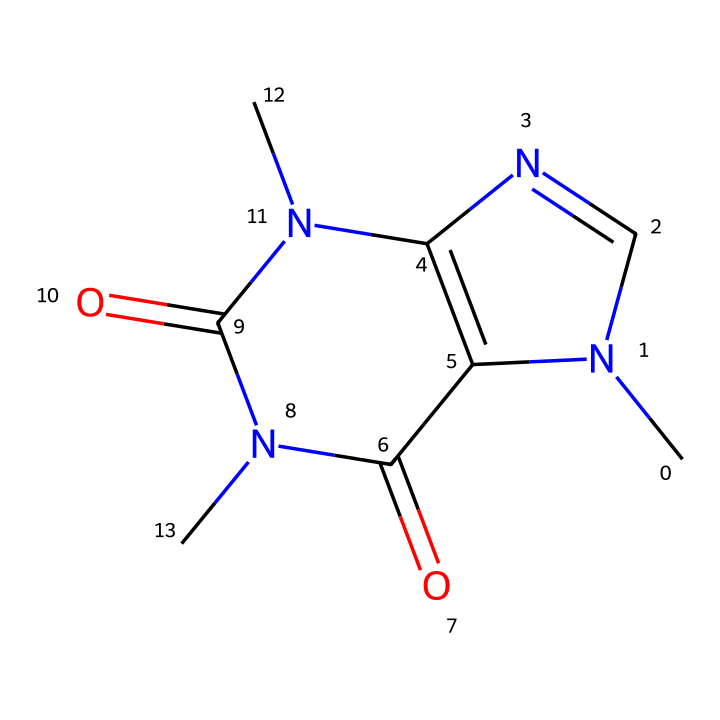What is the molecular formula of caffeine? To find the molecular formula of caffeine, we can analyze the SMILES representation. We identify the constituent atoms in the chemical structure: there are 8 carbon atoms, 10 hydrogen atoms, and 4 nitrogen atoms, along with 2 oxygen atoms. Thus, the molecular formula is C8H10N4O2.
Answer: C8H10N4O2 How many nitrogen atoms are present in caffeine? By examining the SMILES representation, we can count the nitrogen atoms present in the structure. There are 4 nitrogen atoms indicated in the compound.
Answer: 4 What type of functional groups are present in caffeine? Caffeine contains multiple functional groups, mainly amine (due to nitrogen) and carbonyl groups (due to double-bonded oxygen). The presence of these groups influences caffeine's properties significantly.
Answer: amine and carbonyl Is caffeine an aromatic compound? To determine if caffeine is aromatic, we check if it contains a benzene-like structure. Caffeine includes nitrogen atoms in its ring structure, which qualifies it as an aromatic compound due to the presence of conjugated pi electrons around the cyclic structure.
Answer: yes How many rings are in the structure of caffeine? By analyzing the chemical structure through the SMILES, we can identify the presence of rings. Caffeine has two fused rings in its structure, which is characteristic of its classification as a purine derivative.
Answer: 2 Which element in caffeine contributes to its basic properties? The presence of nitrogen is crucial, as nitrogen contributes to the basicity of caffeine. This is due to the lone pair of electrons on the nitrogen atoms that can accept protons.
Answer: nitrogen 